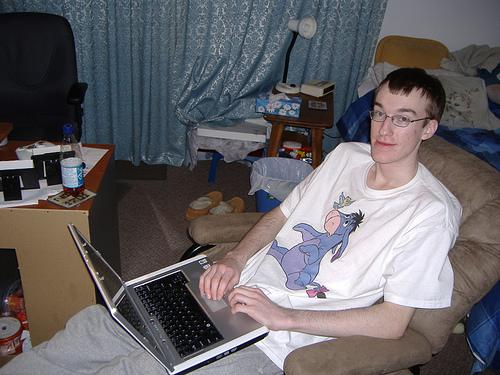Which children's author's creation does this man show off?

Choices:
A) stephen king
B) sendak
C) disney
D) aa milne aa milne 